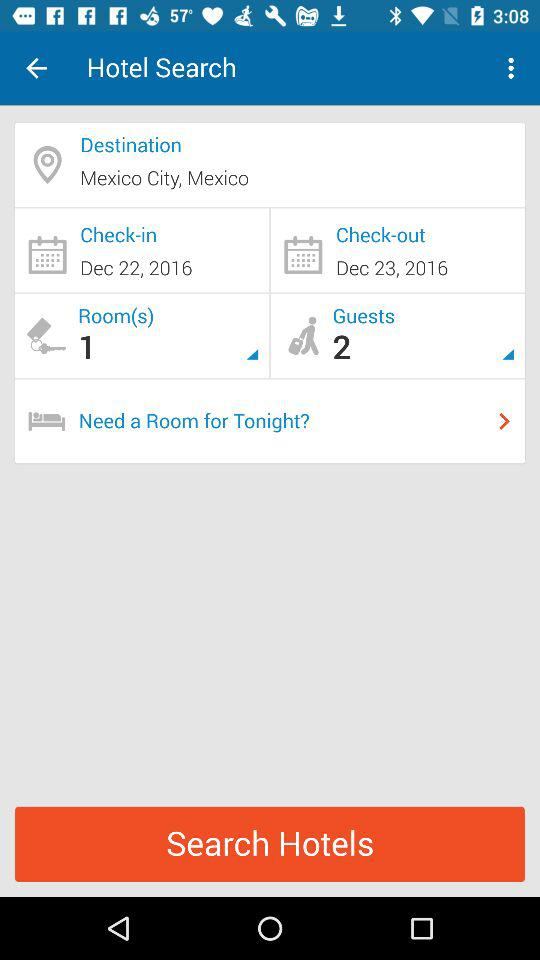How many guests are there? There are 2 guests. 